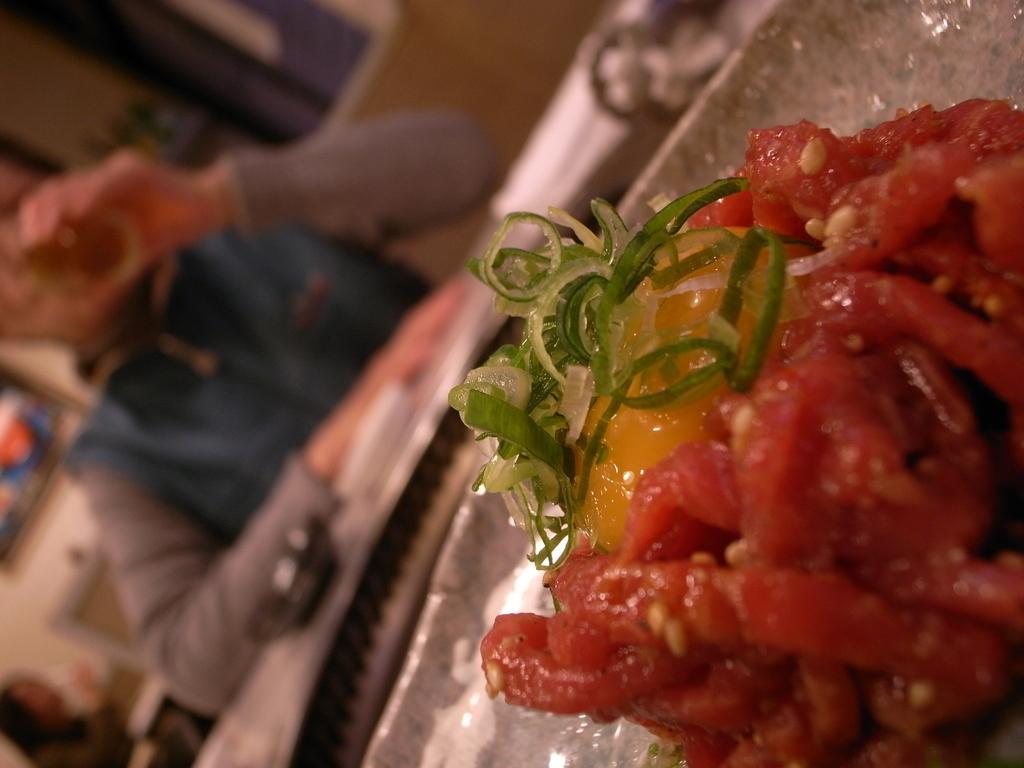In one or two sentences, can you explain what this image depicts? In this image I can see a plate in which food items are there which is kept on the table and a person is sitting on the chair. In the background I can see a wall. This image is taken in a restaurant. 